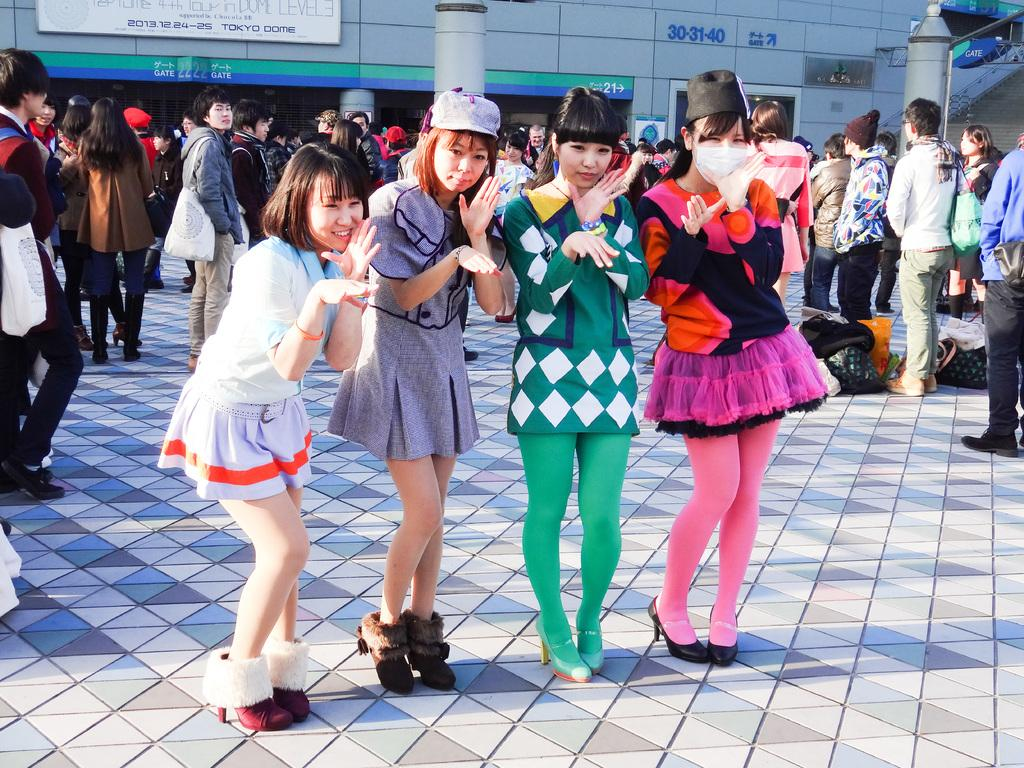How many people are standing in the image? There are four people standing in the image. Can you describe the surroundings of the people? There are other people visible in the background, and there is a building in the background as well. What is attached to the building? There is a board attached to the building. What is written on the board? There is text on the board. What type of lip balm is being advertised on the board in the image? There is no lip balm or advertisement visible on the board in the image; it only has text on it. Is there any mention of sleet in the text on the board? There is no mention of sleet in the text on the board, as the board only contains text and no specific content is described. 